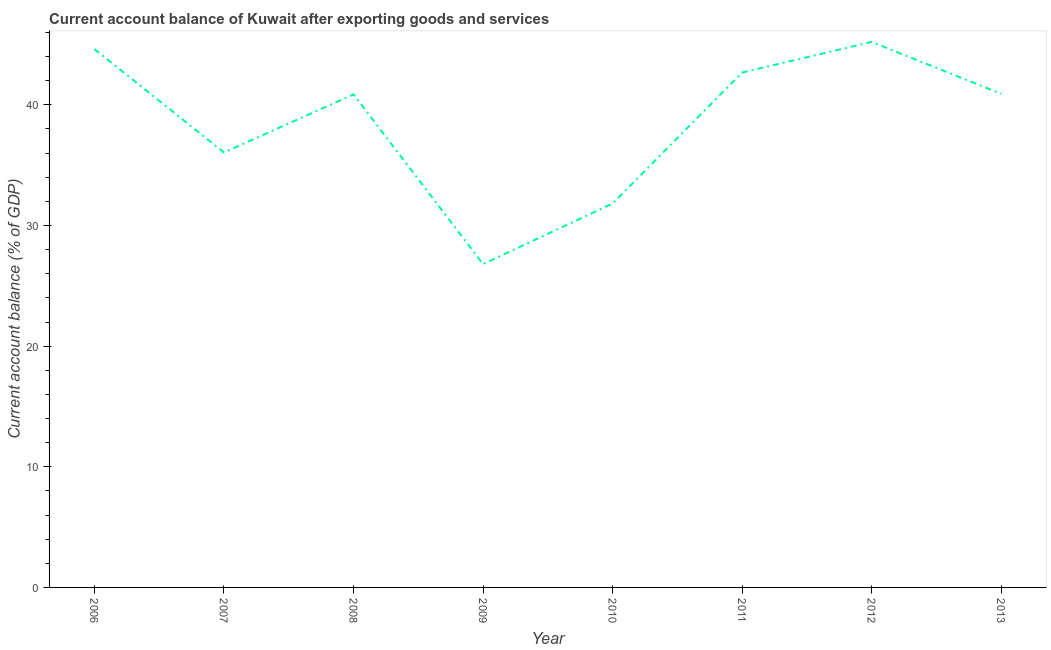What is the current account balance in 2009?
Provide a short and direct response. 26.8. Across all years, what is the maximum current account balance?
Offer a terse response. 45.22. Across all years, what is the minimum current account balance?
Keep it short and to the point. 26.8. In which year was the current account balance maximum?
Your answer should be very brief. 2012. In which year was the current account balance minimum?
Offer a terse response. 2009. What is the sum of the current account balance?
Your answer should be very brief. 308.98. What is the difference between the current account balance in 2007 and 2012?
Provide a succinct answer. -9.16. What is the average current account balance per year?
Give a very brief answer. 38.62. What is the median current account balance?
Make the answer very short. 40.89. Do a majority of the years between 2013 and 2008 (inclusive) have current account balance greater than 10 %?
Keep it short and to the point. Yes. What is the ratio of the current account balance in 2007 to that in 2013?
Offer a very short reply. 0.88. Is the current account balance in 2009 less than that in 2012?
Keep it short and to the point. Yes. Is the difference between the current account balance in 2007 and 2008 greater than the difference between any two years?
Make the answer very short. No. What is the difference between the highest and the second highest current account balance?
Offer a terse response. 0.6. What is the difference between the highest and the lowest current account balance?
Give a very brief answer. 18.41. Does the current account balance monotonically increase over the years?
Your answer should be very brief. No. What is the difference between two consecutive major ticks on the Y-axis?
Your answer should be very brief. 10. Are the values on the major ticks of Y-axis written in scientific E-notation?
Keep it short and to the point. No. Does the graph contain any zero values?
Make the answer very short. No. What is the title of the graph?
Provide a short and direct response. Current account balance of Kuwait after exporting goods and services. What is the label or title of the X-axis?
Your answer should be very brief. Year. What is the label or title of the Y-axis?
Give a very brief answer. Current account balance (% of GDP). What is the Current account balance (% of GDP) in 2006?
Make the answer very short. 44.62. What is the Current account balance (% of GDP) in 2007?
Keep it short and to the point. 36.05. What is the Current account balance (% of GDP) of 2008?
Offer a terse response. 40.87. What is the Current account balance (% of GDP) in 2009?
Keep it short and to the point. 26.8. What is the Current account balance (% of GDP) of 2010?
Give a very brief answer. 31.82. What is the Current account balance (% of GDP) in 2011?
Offer a terse response. 42.68. What is the Current account balance (% of GDP) in 2012?
Your answer should be compact. 45.22. What is the Current account balance (% of GDP) in 2013?
Make the answer very short. 40.92. What is the difference between the Current account balance (% of GDP) in 2006 and 2007?
Give a very brief answer. 8.57. What is the difference between the Current account balance (% of GDP) in 2006 and 2008?
Offer a very short reply. 3.75. What is the difference between the Current account balance (% of GDP) in 2006 and 2009?
Your response must be concise. 17.82. What is the difference between the Current account balance (% of GDP) in 2006 and 2010?
Offer a terse response. 12.8. What is the difference between the Current account balance (% of GDP) in 2006 and 2011?
Your answer should be compact. 1.94. What is the difference between the Current account balance (% of GDP) in 2006 and 2012?
Offer a terse response. -0.6. What is the difference between the Current account balance (% of GDP) in 2006 and 2013?
Provide a succinct answer. 3.7. What is the difference between the Current account balance (% of GDP) in 2007 and 2008?
Provide a short and direct response. -4.82. What is the difference between the Current account balance (% of GDP) in 2007 and 2009?
Make the answer very short. 9.25. What is the difference between the Current account balance (% of GDP) in 2007 and 2010?
Your response must be concise. 4.23. What is the difference between the Current account balance (% of GDP) in 2007 and 2011?
Make the answer very short. -6.63. What is the difference between the Current account balance (% of GDP) in 2007 and 2012?
Your response must be concise. -9.16. What is the difference between the Current account balance (% of GDP) in 2007 and 2013?
Your answer should be very brief. -4.87. What is the difference between the Current account balance (% of GDP) in 2008 and 2009?
Keep it short and to the point. 14.07. What is the difference between the Current account balance (% of GDP) in 2008 and 2010?
Your response must be concise. 9.05. What is the difference between the Current account balance (% of GDP) in 2008 and 2011?
Offer a terse response. -1.81. What is the difference between the Current account balance (% of GDP) in 2008 and 2012?
Keep it short and to the point. -4.35. What is the difference between the Current account balance (% of GDP) in 2008 and 2013?
Your answer should be compact. -0.05. What is the difference between the Current account balance (% of GDP) in 2009 and 2010?
Your answer should be very brief. -5.02. What is the difference between the Current account balance (% of GDP) in 2009 and 2011?
Your response must be concise. -15.88. What is the difference between the Current account balance (% of GDP) in 2009 and 2012?
Keep it short and to the point. -18.41. What is the difference between the Current account balance (% of GDP) in 2009 and 2013?
Give a very brief answer. -14.12. What is the difference between the Current account balance (% of GDP) in 2010 and 2011?
Give a very brief answer. -10.86. What is the difference between the Current account balance (% of GDP) in 2010 and 2012?
Provide a succinct answer. -13.4. What is the difference between the Current account balance (% of GDP) in 2010 and 2013?
Give a very brief answer. -9.1. What is the difference between the Current account balance (% of GDP) in 2011 and 2012?
Your answer should be very brief. -2.54. What is the difference between the Current account balance (% of GDP) in 2011 and 2013?
Provide a succinct answer. 1.76. What is the difference between the Current account balance (% of GDP) in 2012 and 2013?
Your answer should be very brief. 4.3. What is the ratio of the Current account balance (% of GDP) in 2006 to that in 2007?
Provide a short and direct response. 1.24. What is the ratio of the Current account balance (% of GDP) in 2006 to that in 2008?
Give a very brief answer. 1.09. What is the ratio of the Current account balance (% of GDP) in 2006 to that in 2009?
Your answer should be very brief. 1.67. What is the ratio of the Current account balance (% of GDP) in 2006 to that in 2010?
Ensure brevity in your answer.  1.4. What is the ratio of the Current account balance (% of GDP) in 2006 to that in 2011?
Give a very brief answer. 1.04. What is the ratio of the Current account balance (% of GDP) in 2006 to that in 2012?
Provide a succinct answer. 0.99. What is the ratio of the Current account balance (% of GDP) in 2006 to that in 2013?
Make the answer very short. 1.09. What is the ratio of the Current account balance (% of GDP) in 2007 to that in 2008?
Give a very brief answer. 0.88. What is the ratio of the Current account balance (% of GDP) in 2007 to that in 2009?
Offer a terse response. 1.34. What is the ratio of the Current account balance (% of GDP) in 2007 to that in 2010?
Keep it short and to the point. 1.13. What is the ratio of the Current account balance (% of GDP) in 2007 to that in 2011?
Make the answer very short. 0.84. What is the ratio of the Current account balance (% of GDP) in 2007 to that in 2012?
Give a very brief answer. 0.8. What is the ratio of the Current account balance (% of GDP) in 2007 to that in 2013?
Your response must be concise. 0.88. What is the ratio of the Current account balance (% of GDP) in 2008 to that in 2009?
Offer a terse response. 1.52. What is the ratio of the Current account balance (% of GDP) in 2008 to that in 2010?
Keep it short and to the point. 1.28. What is the ratio of the Current account balance (% of GDP) in 2008 to that in 2011?
Give a very brief answer. 0.96. What is the ratio of the Current account balance (% of GDP) in 2008 to that in 2012?
Provide a short and direct response. 0.9. What is the ratio of the Current account balance (% of GDP) in 2009 to that in 2010?
Make the answer very short. 0.84. What is the ratio of the Current account balance (% of GDP) in 2009 to that in 2011?
Ensure brevity in your answer.  0.63. What is the ratio of the Current account balance (% of GDP) in 2009 to that in 2012?
Your answer should be compact. 0.59. What is the ratio of the Current account balance (% of GDP) in 2009 to that in 2013?
Your answer should be very brief. 0.66. What is the ratio of the Current account balance (% of GDP) in 2010 to that in 2011?
Offer a terse response. 0.75. What is the ratio of the Current account balance (% of GDP) in 2010 to that in 2012?
Keep it short and to the point. 0.7. What is the ratio of the Current account balance (% of GDP) in 2010 to that in 2013?
Your response must be concise. 0.78. What is the ratio of the Current account balance (% of GDP) in 2011 to that in 2012?
Your answer should be very brief. 0.94. What is the ratio of the Current account balance (% of GDP) in 2011 to that in 2013?
Your response must be concise. 1.04. What is the ratio of the Current account balance (% of GDP) in 2012 to that in 2013?
Keep it short and to the point. 1.1. 